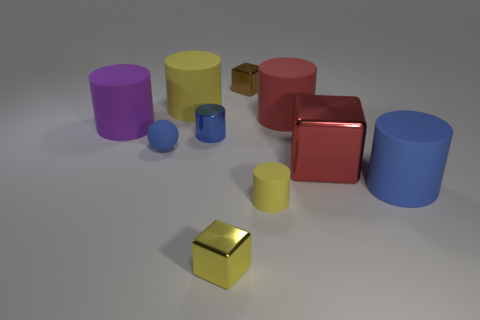Subtract 3 cylinders. How many cylinders are left? 3 Subtract all blue cylinders. How many cylinders are left? 4 Subtract all small metal cylinders. How many cylinders are left? 5 Subtract all green cylinders. Subtract all cyan spheres. How many cylinders are left? 6 Subtract all cylinders. How many objects are left? 4 Subtract all small green metallic spheres. Subtract all large yellow matte things. How many objects are left? 9 Add 8 blue rubber balls. How many blue rubber balls are left? 9 Add 4 purple matte balls. How many purple matte balls exist? 4 Subtract 0 red balls. How many objects are left? 10 